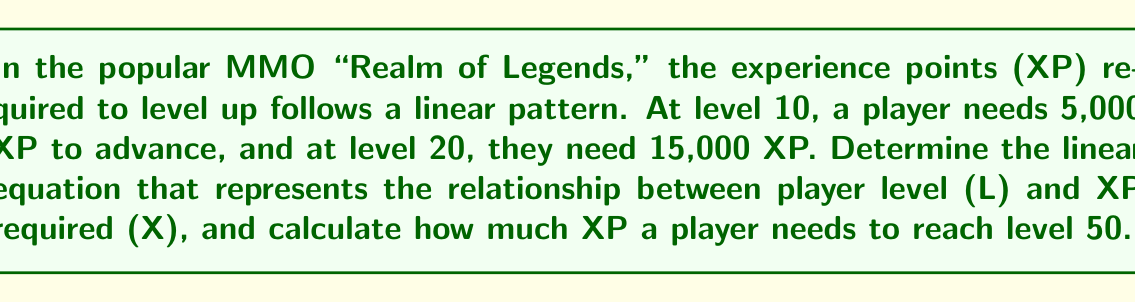Show me your answer to this math problem. Let's approach this step-by-step:

1) We're looking for a linear equation in the form $X = mL + b$, where:
   $X$ = XP required
   $L$ = Player level
   $m$ = Slope (XP increase per level)
   $b$ = Y-intercept (theoretical XP at level 0)

2) We have two points:
   $(L_1, X_1) = (10, 5000)$
   $(L_2, X_2) = (20, 15000)$

3) Calculate the slope:
   $m = \frac{X_2 - X_1}{L_2 - L_1} = \frac{15000 - 5000}{20 - 10} = \frac{10000}{10} = 1000$

4) Use the point-slope form with $(10, 5000)$:
   $X - 5000 = 1000(L - 10)$

5) Simplify to slope-intercept form:
   $X = 1000L - 10000 + 5000$
   $X = 1000L - 5000$

6) This is our linear equation. To find XP for level 50:
   $X = 1000(50) - 5000$
   $X = 50000 - 5000 = 45000$

Therefore, a player needs 45,000 XP to reach level 50.
Answer: $X = 1000L - 5000$; 45,000 XP 